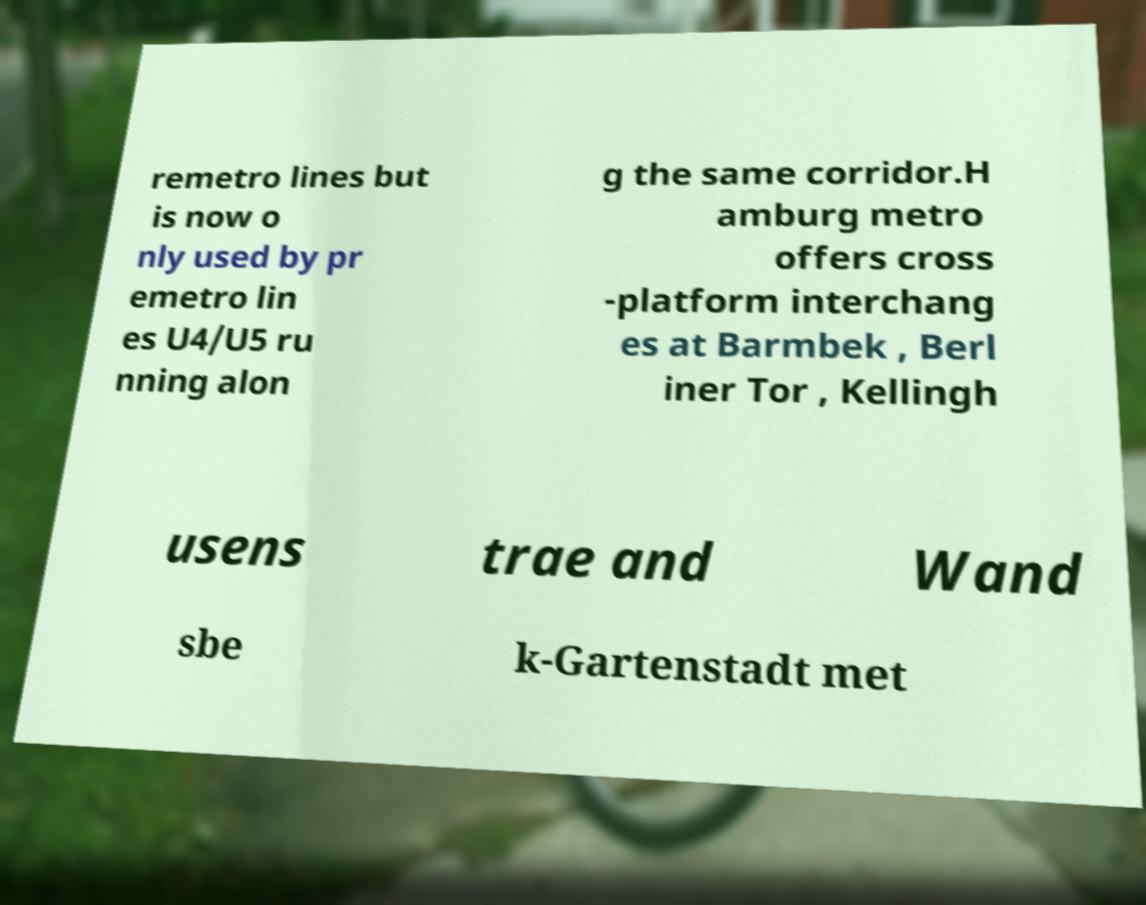I need the written content from this picture converted into text. Can you do that? remetro lines but is now o nly used by pr emetro lin es U4/U5 ru nning alon g the same corridor.H amburg metro offers cross -platform interchang es at Barmbek , Berl iner Tor , Kellingh usens trae and Wand sbe k-Gartenstadt met 